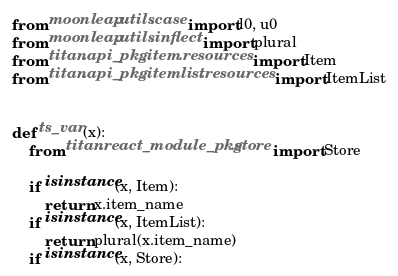<code> <loc_0><loc_0><loc_500><loc_500><_Python_>from moonleap.utils.case import l0, u0
from moonleap.utils.inflect import plural
from titan.api_pkg.item.resources import Item
from titan.api_pkg.itemlist.resources import ItemList


def ts_var(x):
    from titan.react_module_pkg.store import Store

    if isinstance(x, Item):
        return x.item_name
    if isinstance(x, ItemList):
        return plural(x.item_name)
    if isinstance(x, Store):</code> 